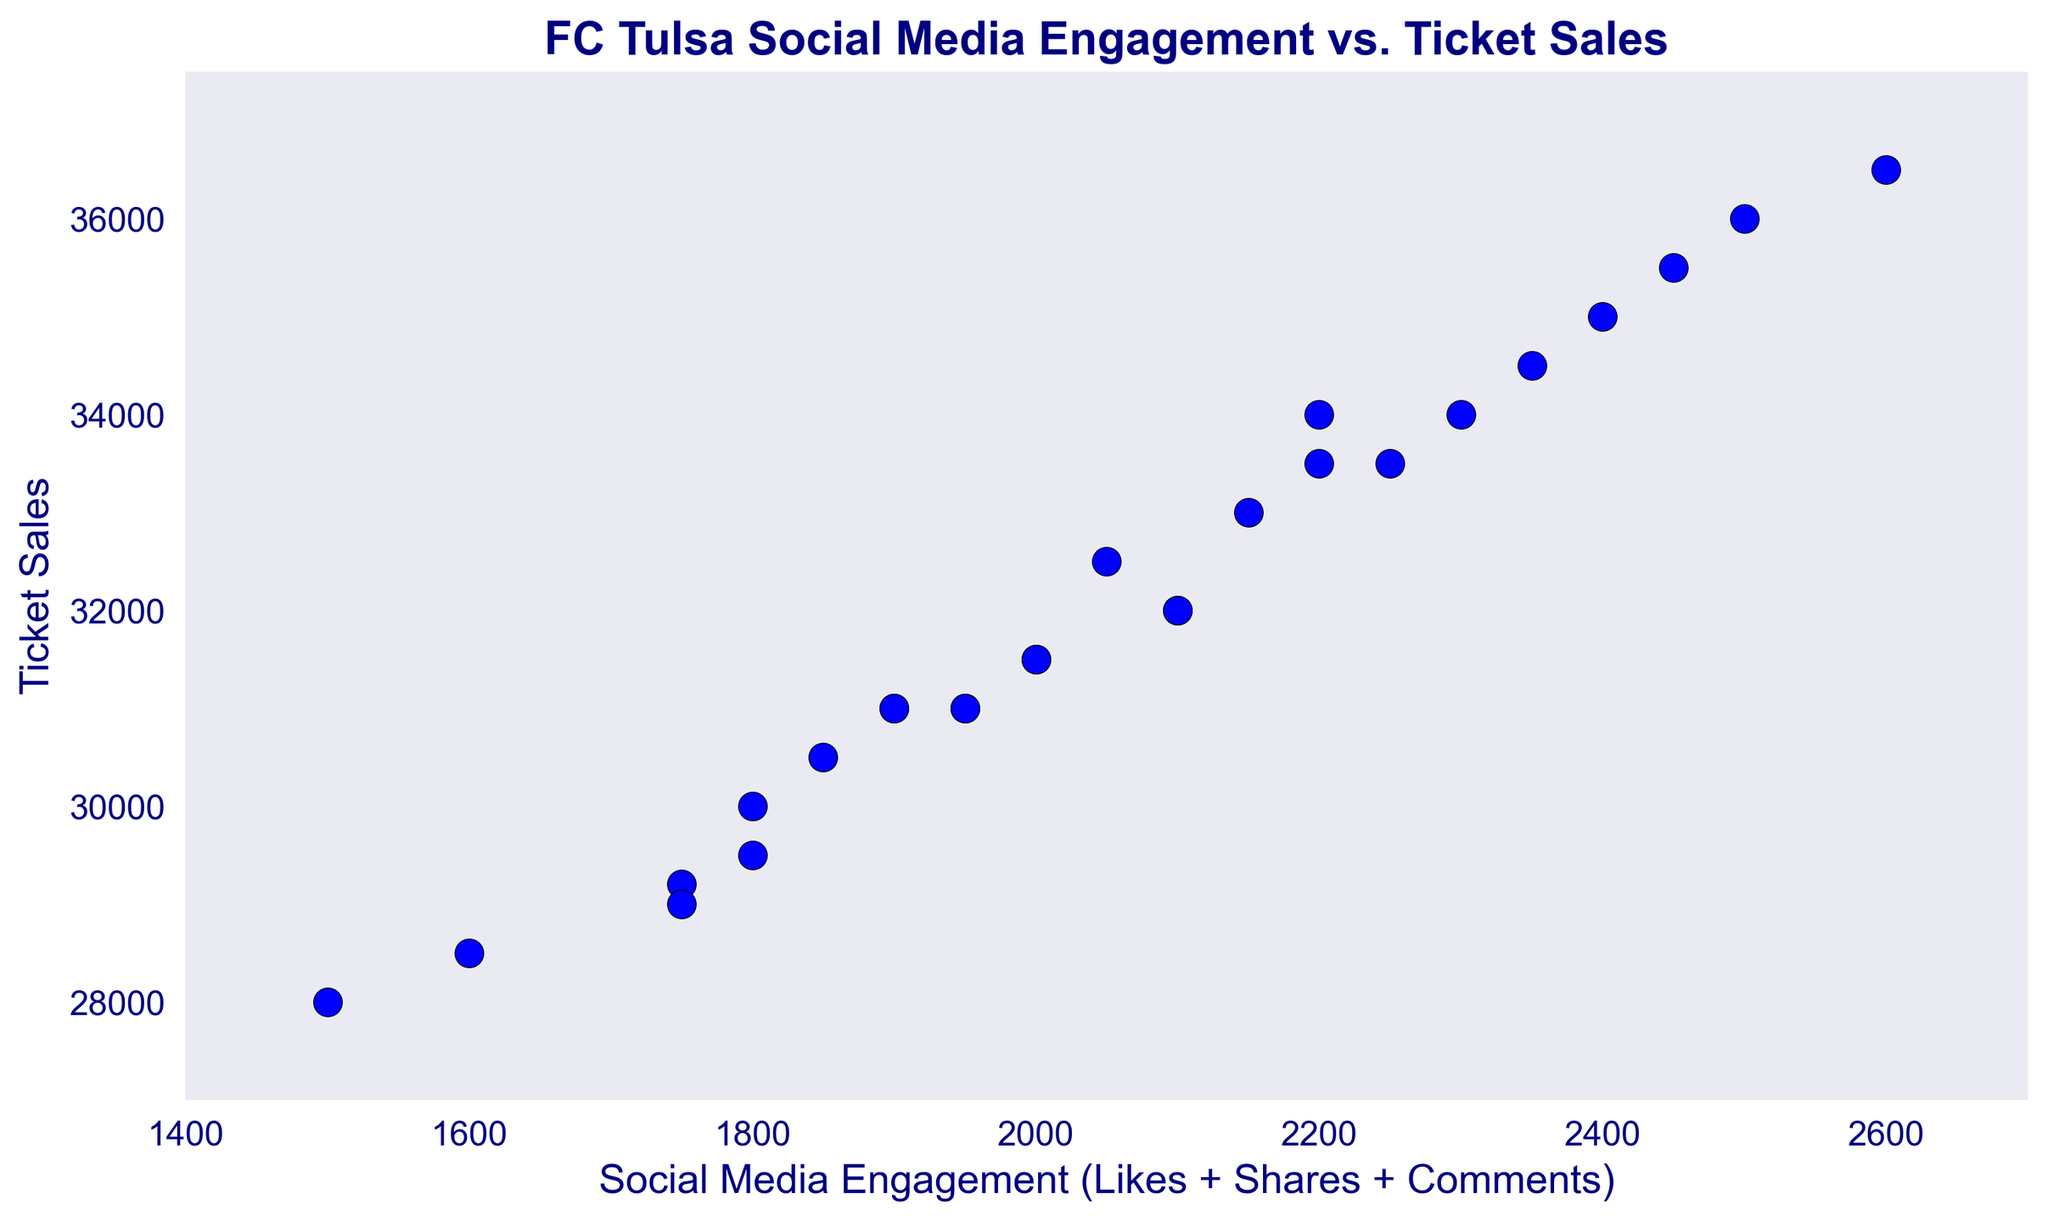What is the range of social media engagement values in the scatter plot? The range of social media engagement is calculated by finding the difference between the maximum and minimum values. The highest value is 2600 and the lowest is 1500. So, the range is 2600 - 1500 = 1100.
Answer: 1100 What is the average ticket sales figure? To find the average, sum up all the ticket sales values and divide by the number of weeks. Sum = 28000 + 29200 + 31000 + 28500 + 32000 + 33500 + 30000 + 31500 + 31000 + 34000 + 30500 + 35000 + 32500 + 36000 + 31000 + 36500 + 33500 + 29500 + 32000 + 34500 + 31500 + 29000 + 35500 + 33000 + 31000 + 34000 = 832700. Number of weeks = 26. So, average = 832700 / 26 ≈ 32027.
Answer: 32027 Which week shows the highest ticket sales and what is the value? The week with the highest ticket sales is found by looking at the y-axis for the highest value, which is 36500. Referring to the dataset, week 16 has the highest sales at 36500.
Answer: Week 16, 36500 Is there a general trend between social media engagement and ticket sales? By observing the scatter plot, there appears to be a positive correlation where higher social media engagement generally corresponds to higher ticket sales.
Answer: Positive correlation Which week had the lowest social media engagement, and how many ticket sales did it achieve? The week with the lowest social media engagement is week 1, with 1500 engagements. Corresponding ticket sales for this week is 28000.
Answer: Week 1, 28000 Compare the ticket sales between weeks with social media engagement of 1750. Are they similar or different? In the dataset, weeks with social media engagement of 1750 are weeks 2 and 22. The ticket sales for week 2 is 29200 and for week 22 is 29000. These values are very close to each other.
Answer: Similar, 29200 and 29000 What changes in ticket sales can be observed when social media engagement increases from 1600 to 2400? When social media engagement increases from 1600 (week 4) to 2400 (week 12), ticket sales rise from 28500 to 35000. This shows a significant increase of 6500 in ticket sales.
Answer: Increase of 6500 Based on the scatter plot, what is the ticket sales value for a social media engagement of 2200? Referring to the scatter plot, weeks with social media engagement of 2200 are week 6 and week 26, with ticket sales values of 33500 and 34000 respectively.
Answer: 33500 or 34000 What is the median value of social media engagement? To find the median, sort the engagement values and find the middle value. Sorted values: 1500, 1600, 1750, 1750, 1800, 1800, 1850, 1900, 1900, 1950, 1950, 2000, 2000, 2050, 2100, 2100, 2150, 2200, 2200, 2250, 2300, 2350, 2400, 2450, 2500, 2600. The middle values (14th and 13th) are 2100 and 2050, respectively, so the median is (2100 + 2050)/2 = 2075.
Answer: 2075 If social media engagement is 2500, which week does it correspond to and what are the ticket sales? Week 14 has social media engagement of 2500 and the ticket sales for this week are 36000.
Answer: Week 14, 36000 